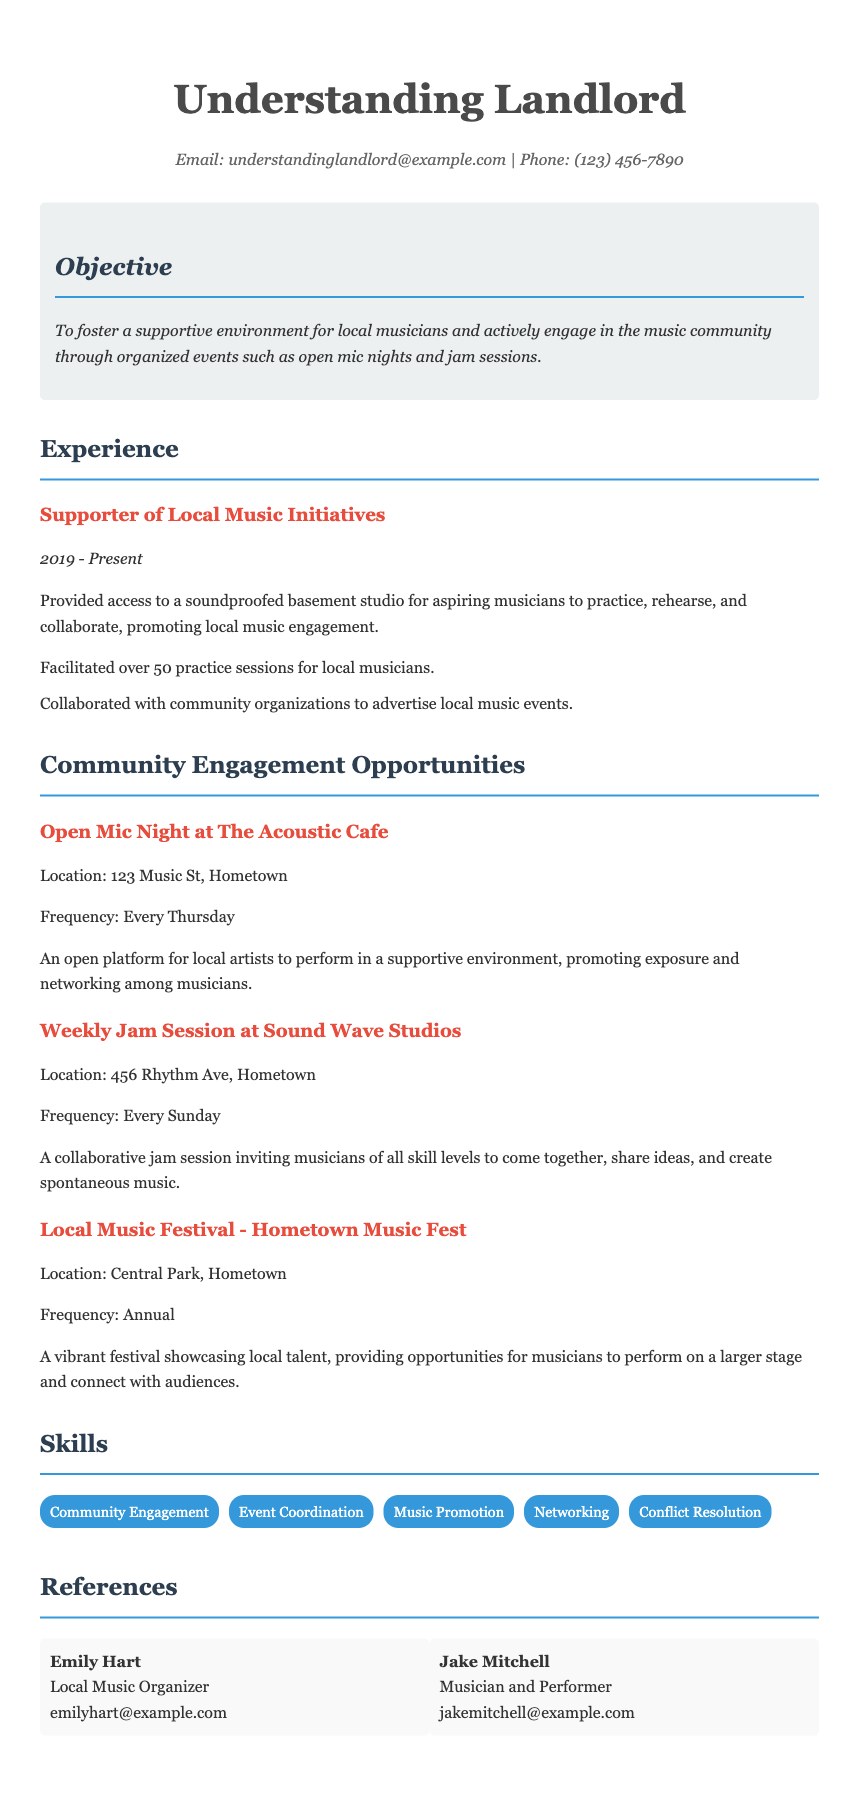What is the objective stated in the CV? The objective is to foster a supportive environment for local musicians and actively engage in the music community through organized events.
Answer: Foster a supportive environment for local musicians How many practice sessions have been facilitated for local musicians? The CV states that over 50 practice sessions have been facilitated.
Answer: Over 50 What is the frequency of the Open Mic Night at The Acoustic Cafe? The frequency of the Open Mic Night is mentioned as every Thursday.
Answer: Every Thursday Where is the location of the Local Music Festival? The location for the Local Music Festival is Central Park, Hometown.
Answer: Central Park, Hometown What type of session is held at Sound Wave Studios? The session held is described as a collaborative jam session.
Answer: Collaborative jam session Who is the contact for local music organization listed in the references? Emily Hart is listed as a contact for local music organization.
Answer: Emily Hart What is the primary purpose of hosting local music engagement opportunities according to the CV? The document mentions promoting exposure and networking among musicians as the primary purpose.
Answer: Promoting exposure and networking What skills are highlighted in the CV under the skills section? Skills mentioned include community engagement, event coordination, music promotion, networking, and conflict resolution.
Answer: Community engagement, event coordination, music promotion, networking, conflict resolution 